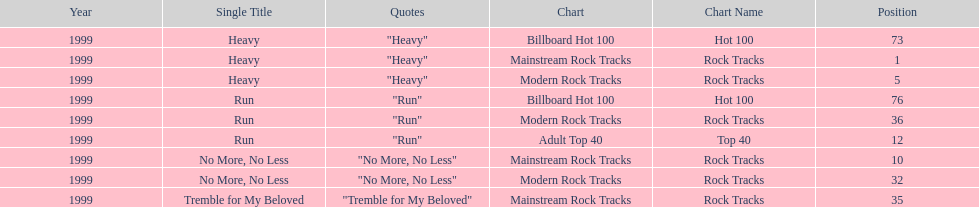How many different charts did "run" make? 3. 